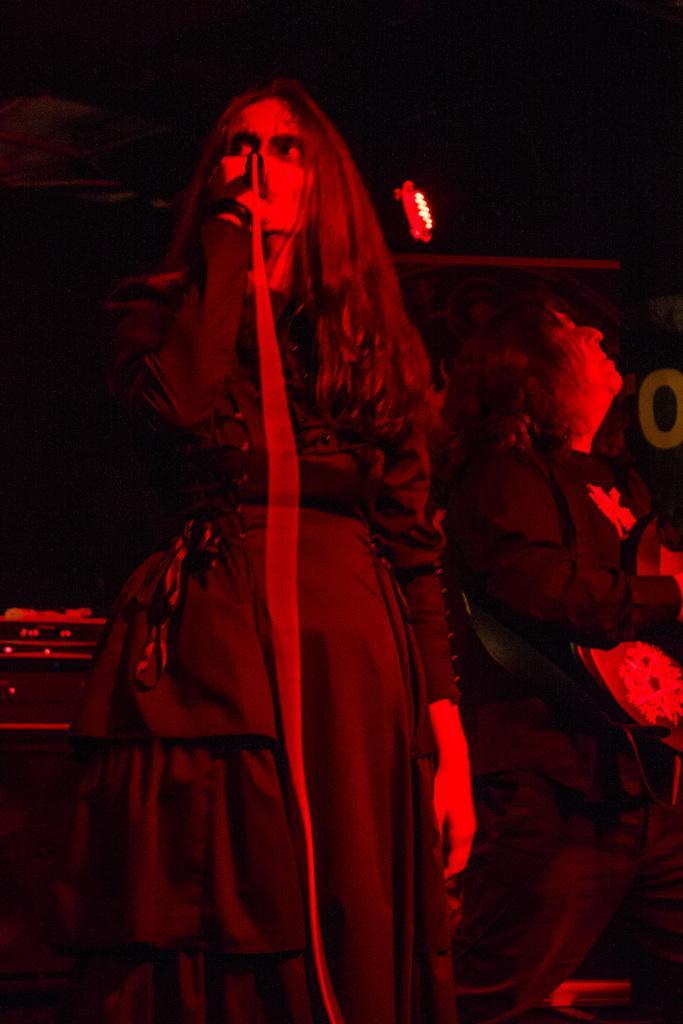Describe this image in one or two sentences. In this image I can see two people with the dresses. I can see one person holding the mic. In the back I can see the light and there is a black background. 